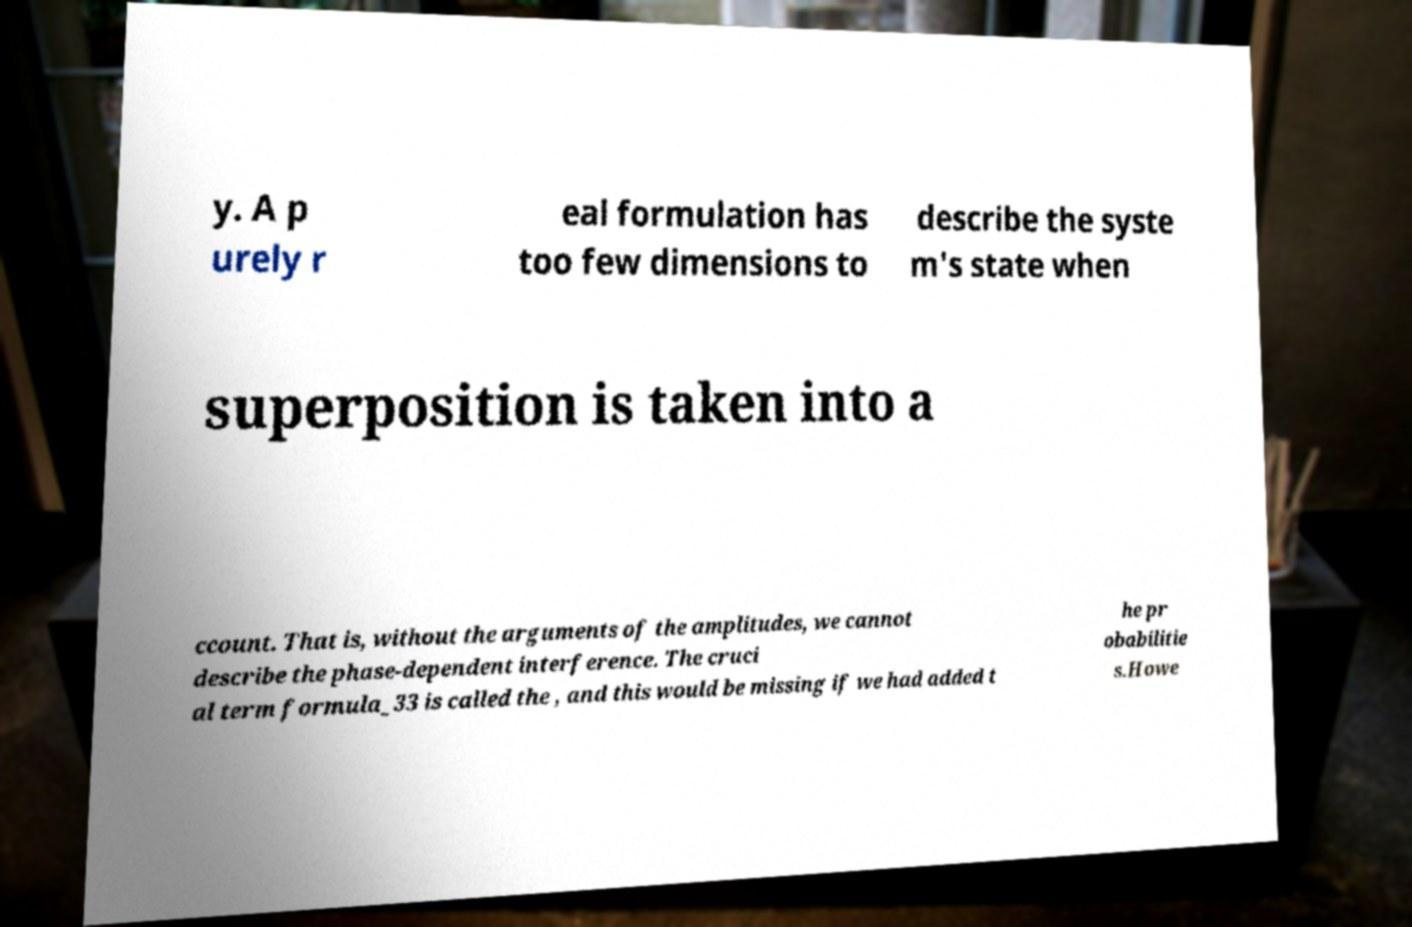Please read and relay the text visible in this image. What does it say? y. A p urely r eal formulation has too few dimensions to describe the syste m's state when superposition is taken into a ccount. That is, without the arguments of the amplitudes, we cannot describe the phase-dependent interference. The cruci al term formula_33 is called the , and this would be missing if we had added t he pr obabilitie s.Howe 